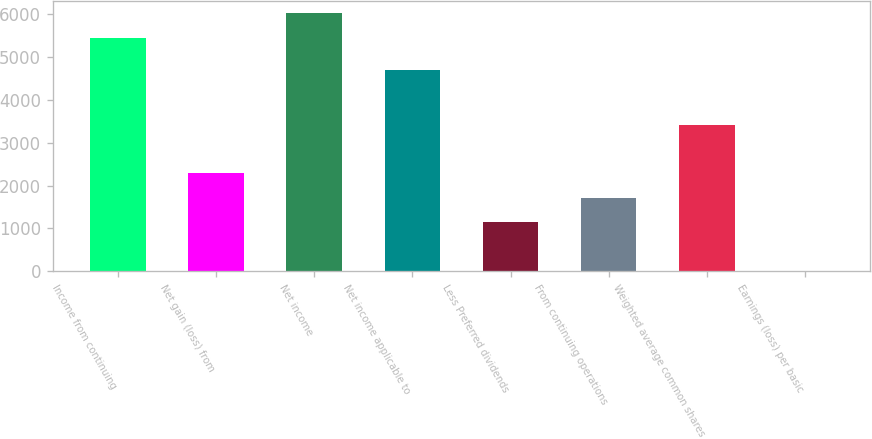Convert chart. <chart><loc_0><loc_0><loc_500><loc_500><bar_chart><fcel>Income from continuing<fcel>Net gain (loss) from<fcel>Net income<fcel>Net income applicable to<fcel>Less Preferred dividends<fcel>From continuing operations<fcel>Weighted average common shares<fcel>Earnings (loss) per basic<nl><fcel>5455<fcel>2282.4<fcel>6024.94<fcel>4703<fcel>1142.52<fcel>1712.46<fcel>3422.28<fcel>2.64<nl></chart> 